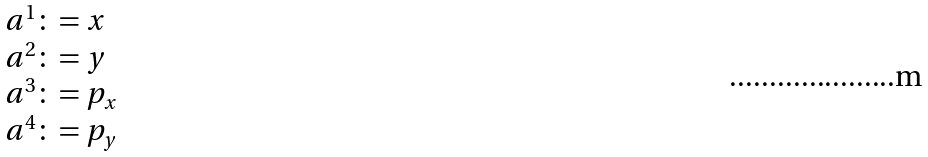Convert formula to latex. <formula><loc_0><loc_0><loc_500><loc_500>\begin{array} { l } a ^ { 1 } \colon = x \\ a ^ { 2 } \colon = y \\ a ^ { 3 } \colon = p _ { x } \\ a ^ { 4 } \colon = p _ { y } \\ \end{array}</formula> 